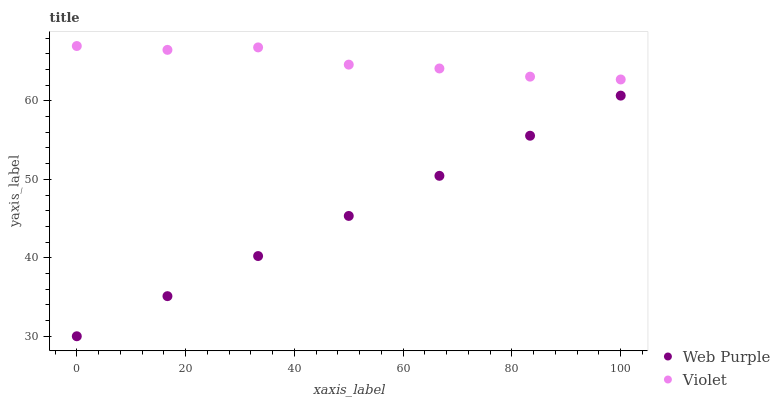Does Web Purple have the minimum area under the curve?
Answer yes or no. Yes. Does Violet have the maximum area under the curve?
Answer yes or no. Yes. Does Violet have the minimum area under the curve?
Answer yes or no. No. Is Web Purple the smoothest?
Answer yes or no. Yes. Is Violet the roughest?
Answer yes or no. Yes. Is Violet the smoothest?
Answer yes or no. No. Does Web Purple have the lowest value?
Answer yes or no. Yes. Does Violet have the lowest value?
Answer yes or no. No. Does Violet have the highest value?
Answer yes or no. Yes. Is Web Purple less than Violet?
Answer yes or no. Yes. Is Violet greater than Web Purple?
Answer yes or no. Yes. Does Web Purple intersect Violet?
Answer yes or no. No. 